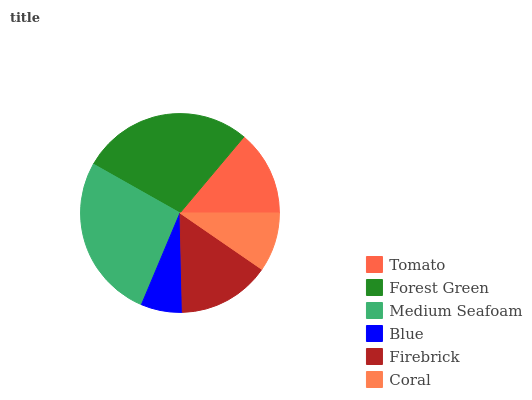Is Blue the minimum?
Answer yes or no. Yes. Is Forest Green the maximum?
Answer yes or no. Yes. Is Medium Seafoam the minimum?
Answer yes or no. No. Is Medium Seafoam the maximum?
Answer yes or no. No. Is Forest Green greater than Medium Seafoam?
Answer yes or no. Yes. Is Medium Seafoam less than Forest Green?
Answer yes or no. Yes. Is Medium Seafoam greater than Forest Green?
Answer yes or no. No. Is Forest Green less than Medium Seafoam?
Answer yes or no. No. Is Firebrick the high median?
Answer yes or no. Yes. Is Tomato the low median?
Answer yes or no. Yes. Is Medium Seafoam the high median?
Answer yes or no. No. Is Blue the low median?
Answer yes or no. No. 